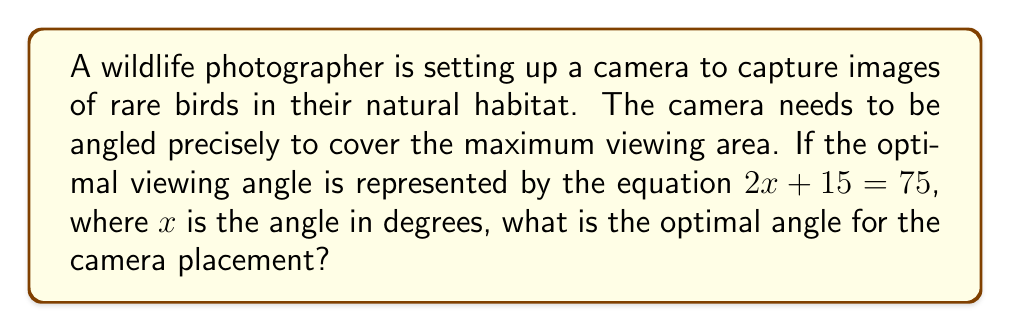Solve this math problem. Let's solve this step-by-step:

1) We start with the equation:
   $2x + 15 = 75$

2) To isolate $x$, first subtract 15 from both sides:
   $2x + 15 - 15 = 75 - 15$
   $2x = 60$

3) Now, divide both sides by 2:
   $\frac{2x}{2} = \frac{60}{2}$
   $x = 30$

4) Therefore, the optimal angle $x$ is 30 degrees.

This angle will provide the best view for capturing images of the rare birds in their natural habitat, allowing the nature enthusiast to appreciate the wildlife while using technology to aid in conservation efforts.
Answer: 30 degrees 